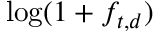Convert formula to latex. <formula><loc_0><loc_0><loc_500><loc_500>\log ( 1 + f _ { t , d } )</formula> 